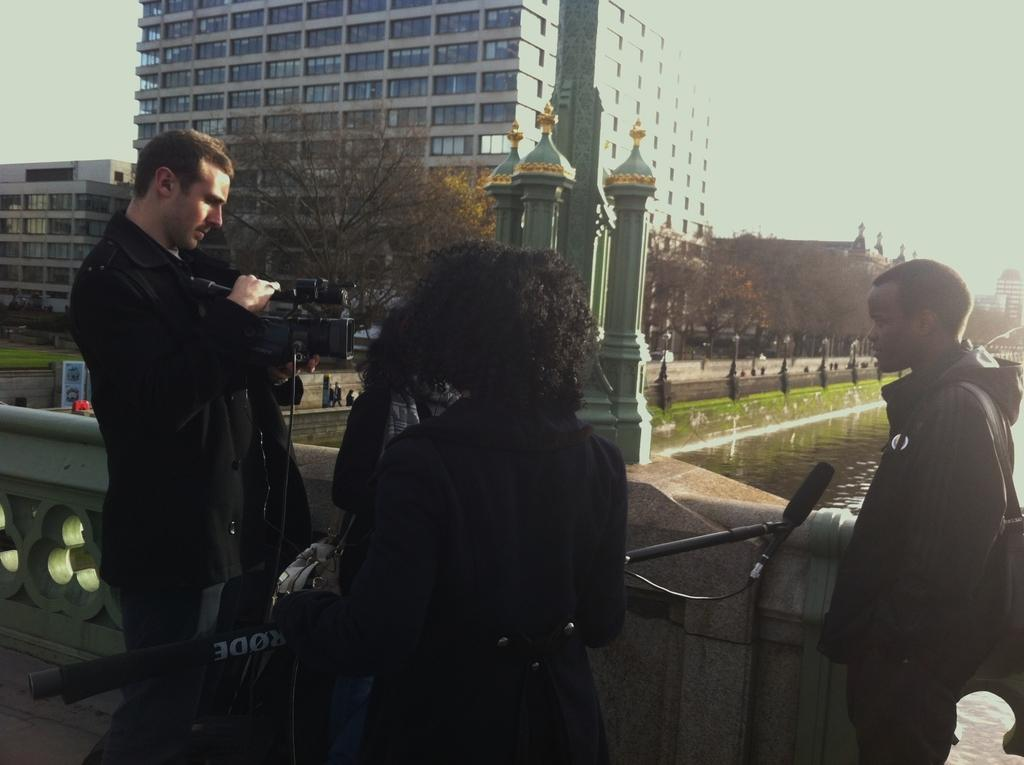How many people are in the foreground of the image? There are three people in the foreground of the image. What are the people doing in the image? The people are working with some equipment. What can be seen in the background of the image? There is a river visible in the background of the image, along with buildings and trees near the river. What type of ladybug can be seen participating in the protest in the image? There is no ladybug or protest present in the image. What are the people learning in the image? The facts provided do not indicate that the people are learning anything in the image. 